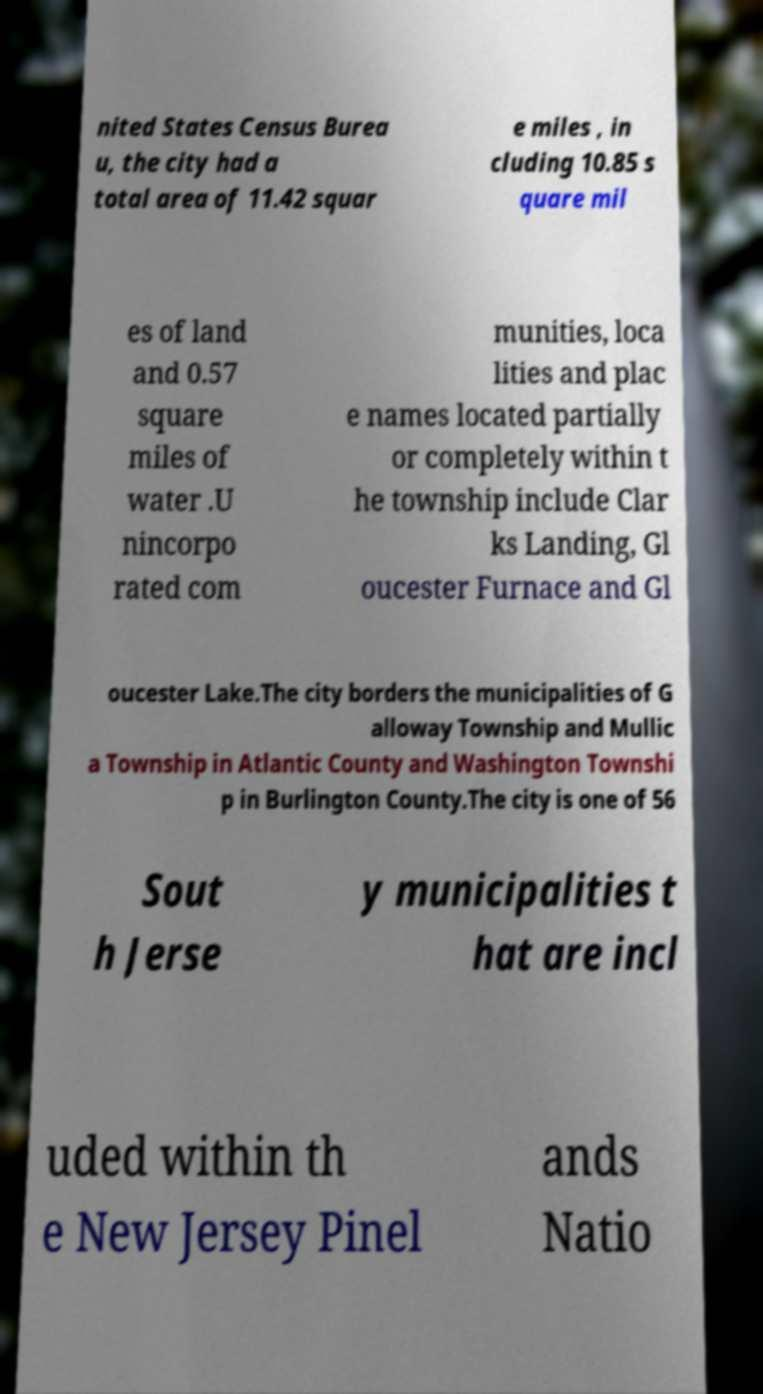Please identify and transcribe the text found in this image. nited States Census Burea u, the city had a total area of 11.42 squar e miles , in cluding 10.85 s quare mil es of land and 0.57 square miles of water .U nincorpo rated com munities, loca lities and plac e names located partially or completely within t he township include Clar ks Landing, Gl oucester Furnace and Gl oucester Lake.The city borders the municipalities of G alloway Township and Mullic a Township in Atlantic County and Washington Townshi p in Burlington County.The city is one of 56 Sout h Jerse y municipalities t hat are incl uded within th e New Jersey Pinel ands Natio 